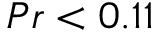Convert formula to latex. <formula><loc_0><loc_0><loc_500><loc_500>{ P r < 0 . 1 1 }</formula> 